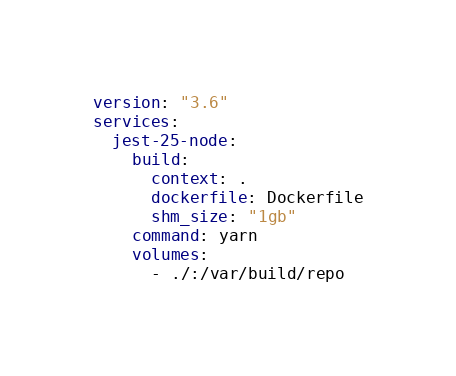Convert code to text. <code><loc_0><loc_0><loc_500><loc_500><_YAML_>version: "3.6"
services:
  jest-25-node:
    build:
      context: .
      dockerfile: Dockerfile
      shm_size: "1gb"
    command: yarn
    volumes:
      - ./:/var/build/repo
</code> 